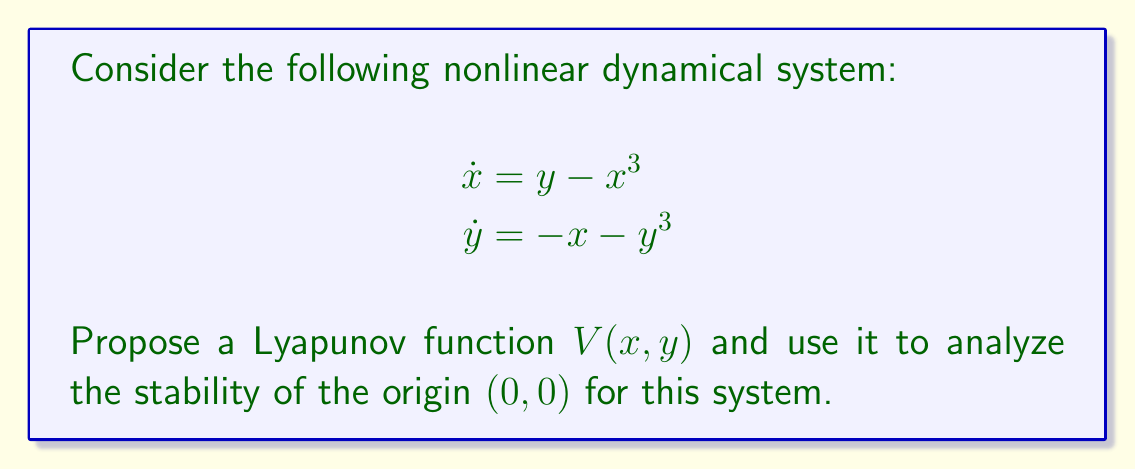Give your solution to this math problem. Let's approach this step-by-step:

1) First, we need to propose a suitable Lyapunov function. Given the symmetry of the system, a natural choice is:

   $$V(x,y) = \frac{1}{2}(x^2 + y^2)$$

2) To analyze stability, we need to check the conditions for Lyapunov stability:
   a) $V(0,0) = 0$
   b) $V(x,y) > 0$ for all $(x,y) \neq (0,0)$
   c) $\dot{V}(x,y) \leq 0$ in a neighborhood of $(0,0)$

3) Let's verify these conditions:
   a) $V(0,0) = \frac{1}{2}(0^2 + 0^2) = 0$ ✓
   b) $V(x,y) = \frac{1}{2}(x^2 + y^2) > 0$ for all $(x,y) \neq (0,0)$ ✓

4) Now, let's calculate $\dot{V}(x,y)$:

   $$\begin{aligned}
   \dot{V}(x,y) &= \frac{\partial V}{\partial x}\dot{x} + \frac{\partial V}{\partial y}\dot{y} \\
   &= x(y-x^3) + y(-x-y^3) \\
   &= xy - x^4 - xy - y^4 \\
   &= -(x^4 + y^4)
   \end{aligned}$$

5) We can see that $\dot{V}(x,y) \leq 0$ for all $(x,y)$, not just in a neighborhood of $(0,0)$. This satisfies condition (c) ✓

6) Since all conditions are satisfied, we can conclude that the origin $(0,0)$ is stable.

7) Moreover, $\dot{V}(x,y) = 0$ only when $x = y = 0$. This means that the origin is the only equilibrium point where the system can stay.

8) By LaSalle's invariance principle, we can conclude that the origin is asymptotically stable.
Answer: The origin $(0,0)$ is asymptotically stable. 